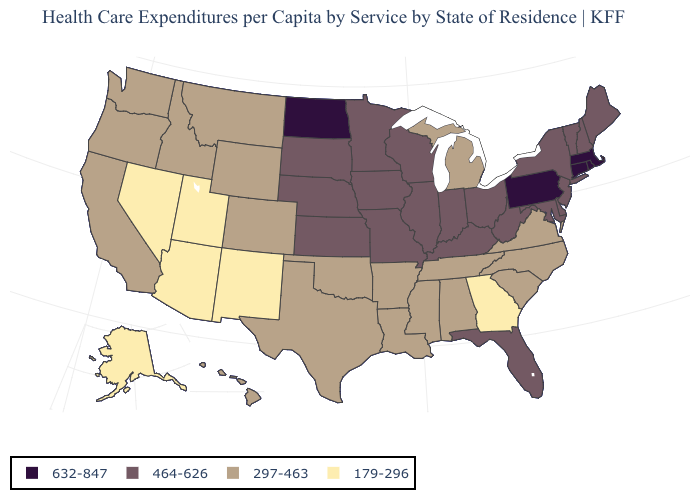What is the highest value in states that border South Dakota?
Give a very brief answer. 632-847. How many symbols are there in the legend?
Short answer required. 4. Is the legend a continuous bar?
Quick response, please. No. What is the lowest value in the MidWest?
Keep it brief. 297-463. What is the value of Hawaii?
Keep it brief. 297-463. Does Nevada have the same value as Illinois?
Give a very brief answer. No. Does Mississippi have a higher value than Virginia?
Write a very short answer. No. What is the highest value in the MidWest ?
Write a very short answer. 632-847. Name the states that have a value in the range 297-463?
Short answer required. Alabama, Arkansas, California, Colorado, Hawaii, Idaho, Louisiana, Michigan, Mississippi, Montana, North Carolina, Oklahoma, Oregon, South Carolina, Tennessee, Texas, Virginia, Washington, Wyoming. Does the first symbol in the legend represent the smallest category?
Write a very short answer. No. What is the value of Oklahoma?
Keep it brief. 297-463. Does the map have missing data?
Quick response, please. No. Name the states that have a value in the range 297-463?
Concise answer only. Alabama, Arkansas, California, Colorado, Hawaii, Idaho, Louisiana, Michigan, Mississippi, Montana, North Carolina, Oklahoma, Oregon, South Carolina, Tennessee, Texas, Virginia, Washington, Wyoming. Does Kentucky have a lower value than Pennsylvania?
Keep it brief. Yes. What is the highest value in the USA?
Quick response, please. 632-847. 